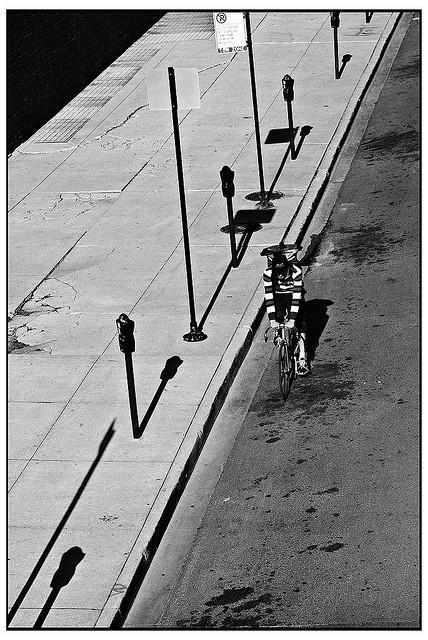How many zebras are there?
Give a very brief answer. 0. 